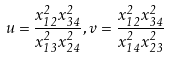<formula> <loc_0><loc_0><loc_500><loc_500>u = \frac { x _ { 1 2 } ^ { 2 } x _ { 3 4 } ^ { 2 } } { x _ { 1 3 } ^ { 2 } x _ { 2 4 } ^ { 2 } } , v = \frac { x _ { 1 2 } ^ { 2 } x _ { 3 4 } ^ { 2 } } { x _ { 1 4 } ^ { 2 } x _ { 2 3 } ^ { 2 } }</formula> 